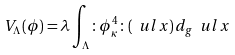<formula> <loc_0><loc_0><loc_500><loc_500>V _ { \Lambda } ( \phi ) = \lambda \int _ { \Lambda } \colon \phi _ { \kappa } ^ { 4 } \colon ( \ u l { x } ) \, d _ { g } \ u l { x }</formula> 